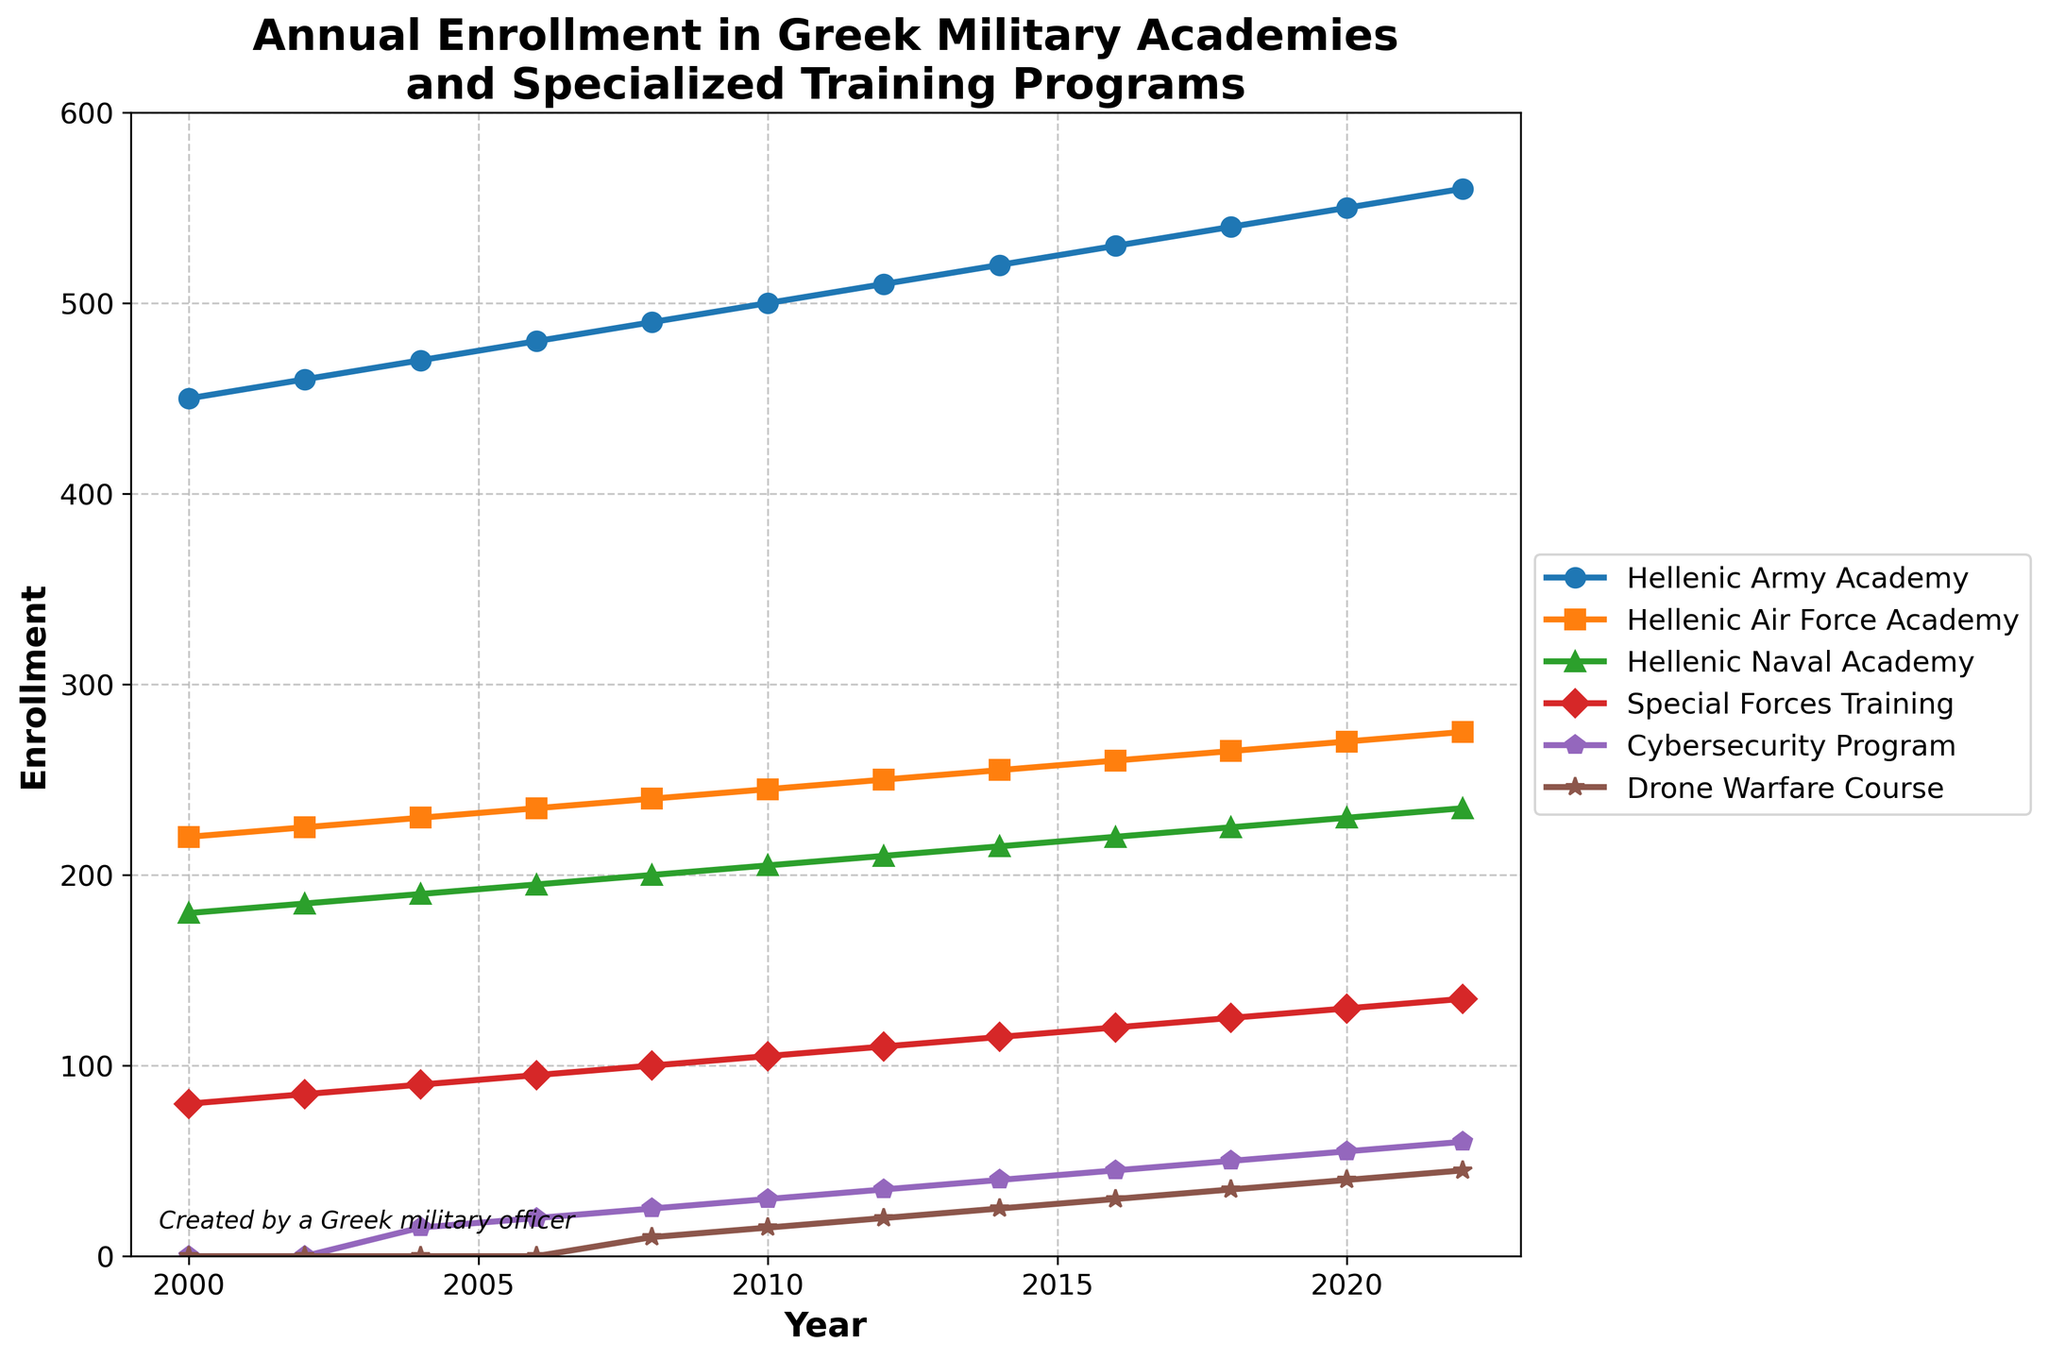What is the trend in the enrollment numbers for the Hellenic Army Academy from 2000 to 2022? The enrollment numbers for the Hellenic Army Academy increase steadily from 450 in 2000 to 560 in 2022. This shows a growing interest or need for army officers over the observed period.
Answer: Steady increase Which academy had the lowest enrollment in 2008? In 2008, the Hellenic Naval Academy had the lowest enrollment with 200 students, compared to the Hellenic Army Academy with 490 and the Hellenic Air Force Academy with 240.
Answer: Hellenic Naval Academy How did the enrollment in the Cybersecurity Program and Drone Warfare Course change from 2004 to 2022? The Cybersecurity Program started in 2004 with 15 enrollees and increased to 60 in 2022, while the Drone Warfare Course started in 2008 with 10 enrollees and rose to 45 in 2022. Both programs show a consistent increase in enrollment over the years, highlighting the growing importance of these technologies in military training.
Answer: Both increased Compare the enrollment numbers in 2022 for the Hellenic Air Force Academy and the Cybersecurity Program. In 2022, the enrollment for the Hellenic Air Force Academy was 275, while the enrollment for the Cybersecurity Program was 60. The Hellenic Air Force Academy had significantly higher enrollment numbers.
Answer: Hellenic Air Force Academy What is the average annual enrollment in the Special Forces Training program over the period from 2000 to 2022? To find the average annual enrollment: Sum the enrollments (80+85+90+95+100+105+110+115+120+125+130+135) which equals 1290, then divide by the number of years (12). The average enrollment is 1290 / 12 = 107.5.
Answer: 107.5 What year saw the highest enrollment increase for the Hellenic Naval Academy, and by how much did it increase? The highest increase in enrollment for the Hellenic Naval Academy occurred from 2016 to 2018. The numbers increased from 220 to 225, an increase of 5 students.
Answer: 2016 to 2018, increased by 5 Are enrollments in the specialized training programs keeping pace with those in the traditional academies? While specialized training programs like Cybersecurity and Drone Warfare show consistent increases, their absolute numbers (60 and 45 in 2022 respectively) are significantly lower compared to the enrollments in traditional academies such as the Hellenic Army Academy (560) or the Hellenic Air Force Academy (275).
Answer: No What was the total enrollment across all programs in 2012? To find the total enrollment in 2012: sum the values across all programs for that year (510 + 250 + 210 + 110 + 35 + 20 = 1135). Thus, the total enrollment in 2012 is 1135.
Answer: 1135 Which program had the smallest percentage increase in enrollments from 2000 to 2022? Percentage increase is calculated by the formula ((final value - initial value) / initial value) * 100. The Hellenic Army Academy showed an increase from 450 to 560, a percentage increase of ((560-450)/450)*100 = 24.44%. The Hellenic Air Force Academy increased from 220 to 275, a 25% increase. The Hellenic Naval Academy increased from 180 to 235, a 30.56% increase. Special Forces Training increased from 80 to 135, a 68.75% increase. Cybersecurity (starting from 15 in 2004) to 60 in 2022, a 300% increase. Drone Warfare Course increased from 10 in 2008 to 45 in 2022, a 350% increase. Thus, the Hellenic Army Academy had the smallest percentage increase (24.44%).
Answer: Hellenic Army Academy 